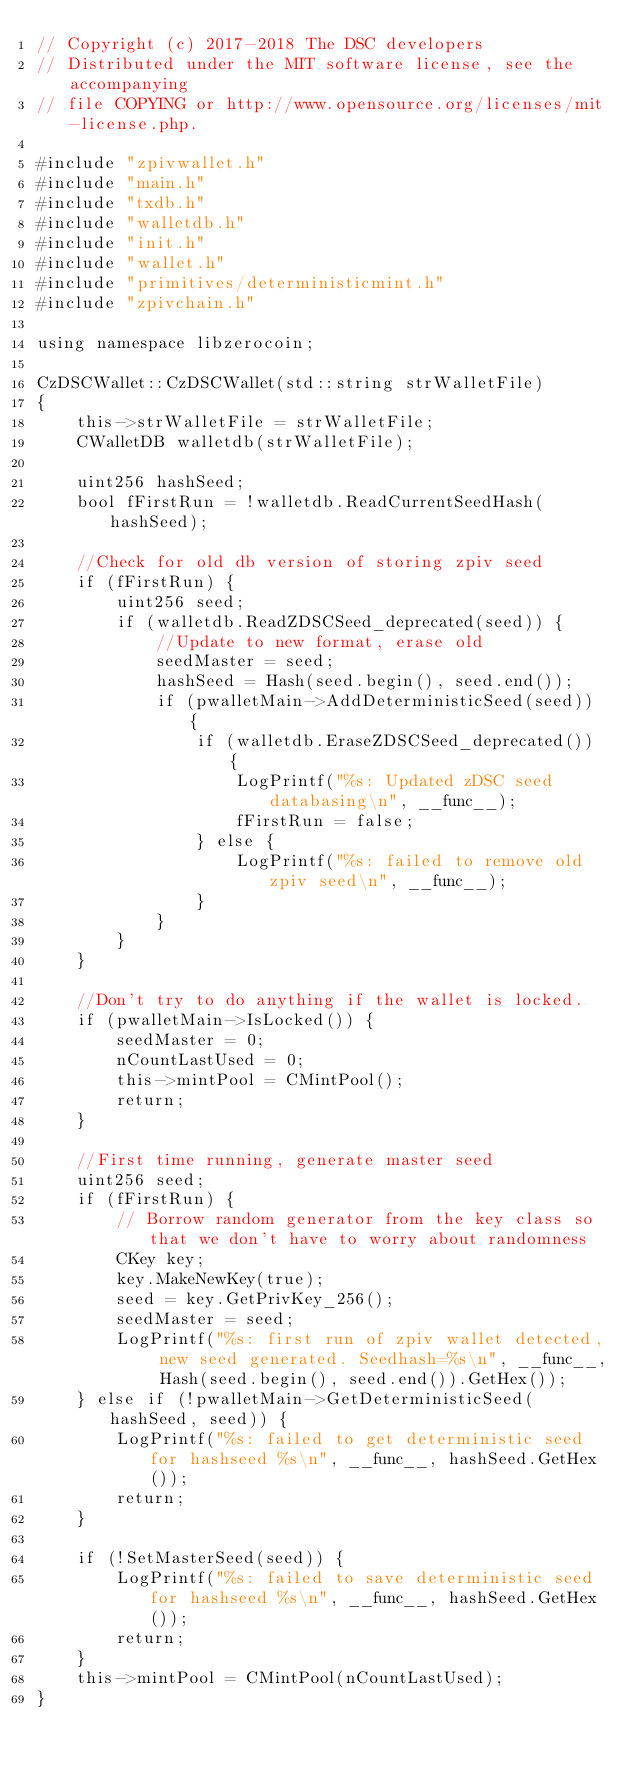Convert code to text. <code><loc_0><loc_0><loc_500><loc_500><_C++_>// Copyright (c) 2017-2018 The DSC developers
// Distributed under the MIT software license, see the accompanying
// file COPYING or http://www.opensource.org/licenses/mit-license.php.

#include "zpivwallet.h"
#include "main.h"
#include "txdb.h"
#include "walletdb.h"
#include "init.h"
#include "wallet.h"
#include "primitives/deterministicmint.h"
#include "zpivchain.h"

using namespace libzerocoin;

CzDSCWallet::CzDSCWallet(std::string strWalletFile)
{
    this->strWalletFile = strWalletFile;
    CWalletDB walletdb(strWalletFile);

    uint256 hashSeed;
    bool fFirstRun = !walletdb.ReadCurrentSeedHash(hashSeed);

    //Check for old db version of storing zpiv seed
    if (fFirstRun) {
        uint256 seed;
        if (walletdb.ReadZDSCSeed_deprecated(seed)) {
            //Update to new format, erase old
            seedMaster = seed;
            hashSeed = Hash(seed.begin(), seed.end());
            if (pwalletMain->AddDeterministicSeed(seed)) {
                if (walletdb.EraseZDSCSeed_deprecated()) {
                    LogPrintf("%s: Updated zDSC seed databasing\n", __func__);
                    fFirstRun = false;
                } else {
                    LogPrintf("%s: failed to remove old zpiv seed\n", __func__);
                }
            }
        }
    }

    //Don't try to do anything if the wallet is locked.
    if (pwalletMain->IsLocked()) {
        seedMaster = 0;
        nCountLastUsed = 0;
        this->mintPool = CMintPool();
        return;
    }

    //First time running, generate master seed
    uint256 seed;
    if (fFirstRun) {
        // Borrow random generator from the key class so that we don't have to worry about randomness
        CKey key;
        key.MakeNewKey(true);
        seed = key.GetPrivKey_256();
        seedMaster = seed;
        LogPrintf("%s: first run of zpiv wallet detected, new seed generated. Seedhash=%s\n", __func__, Hash(seed.begin(), seed.end()).GetHex());
    } else if (!pwalletMain->GetDeterministicSeed(hashSeed, seed)) {
        LogPrintf("%s: failed to get deterministic seed for hashseed %s\n", __func__, hashSeed.GetHex());
        return;
    }

    if (!SetMasterSeed(seed)) {
        LogPrintf("%s: failed to save deterministic seed for hashseed %s\n", __func__, hashSeed.GetHex());
        return;
    }
    this->mintPool = CMintPool(nCountLastUsed);
}
</code> 